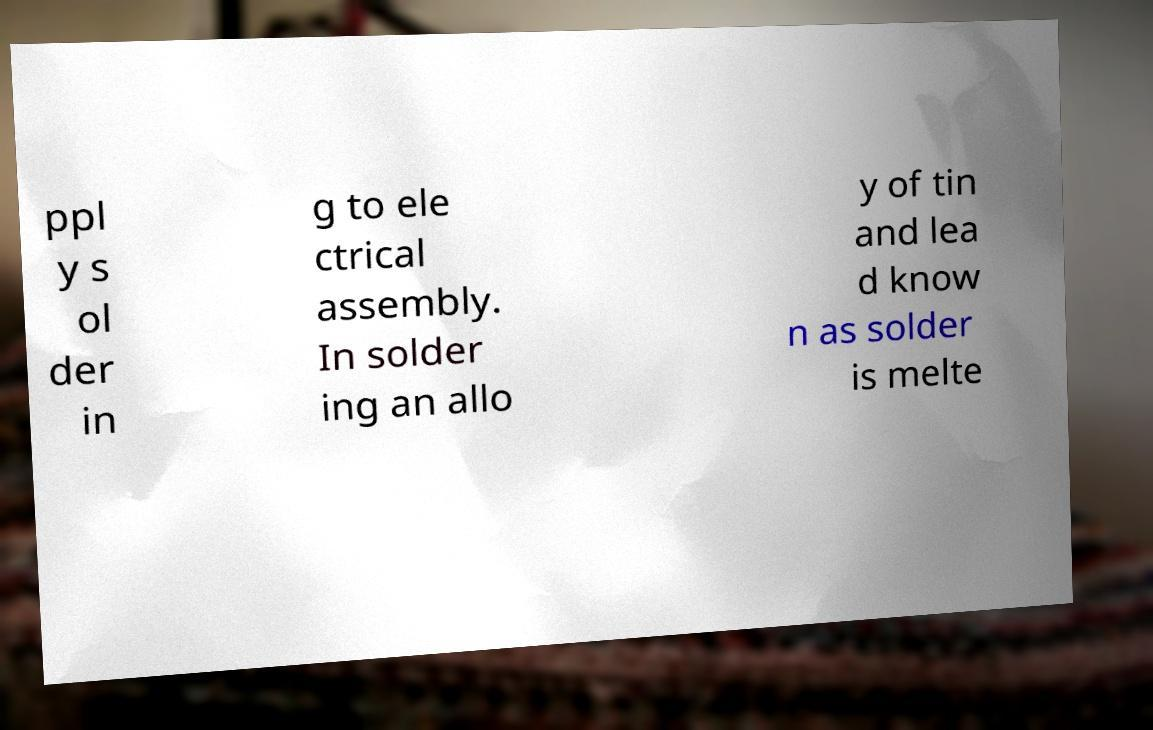What messages or text are displayed in this image? I need them in a readable, typed format. ppl y s ol der in g to ele ctrical assembly. In solder ing an allo y of tin and lea d know n as solder is melte 